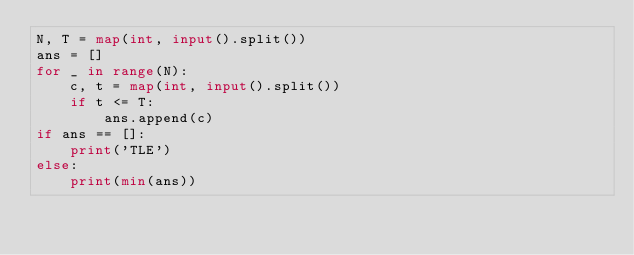Convert code to text. <code><loc_0><loc_0><loc_500><loc_500><_Python_>N, T = map(int, input().split())
ans = []
for _ in range(N):
    c, t = map(int, input().split())
    if t <= T:
        ans.append(c)
if ans == []:
    print('TLE')
else:
    print(min(ans))    
    </code> 